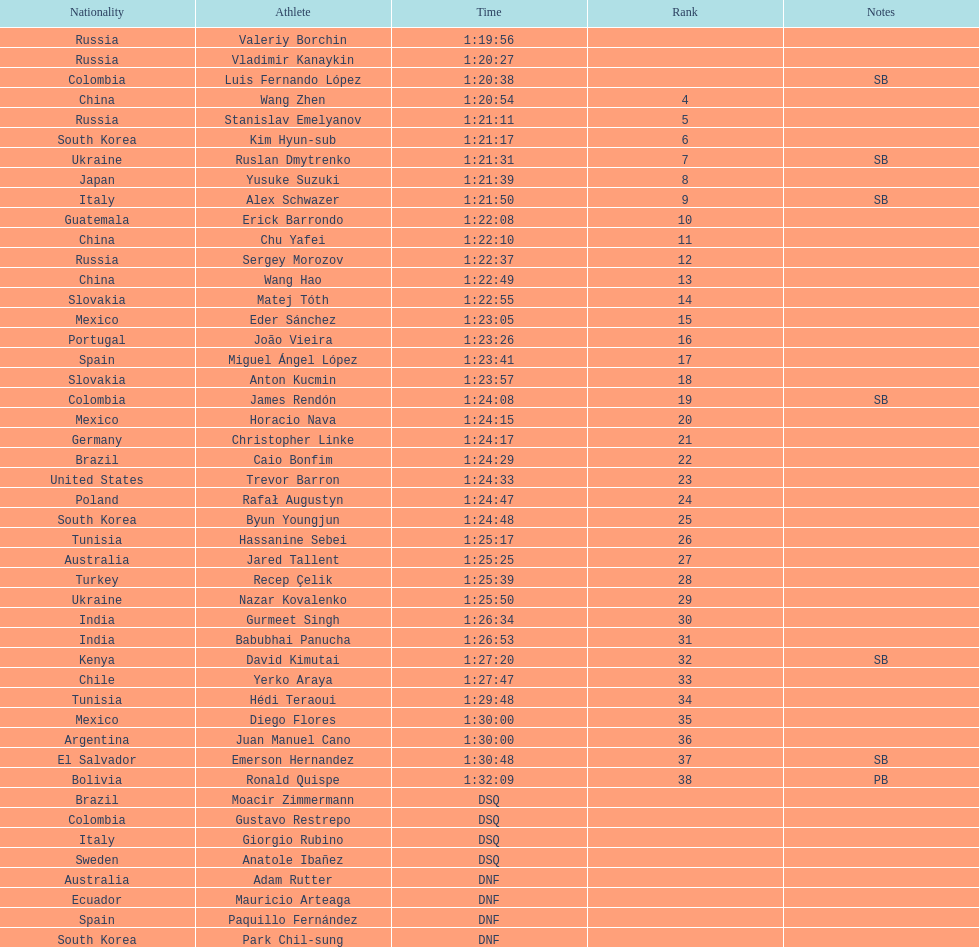Name all athletes were slower than horacio nava. Christopher Linke, Caio Bonfim, Trevor Barron, Rafał Augustyn, Byun Youngjun, Hassanine Sebei, Jared Tallent, Recep Çelik, Nazar Kovalenko, Gurmeet Singh, Babubhai Panucha, David Kimutai, Yerko Araya, Hédi Teraoui, Diego Flores, Juan Manuel Cano, Emerson Hernandez, Ronald Quispe. 